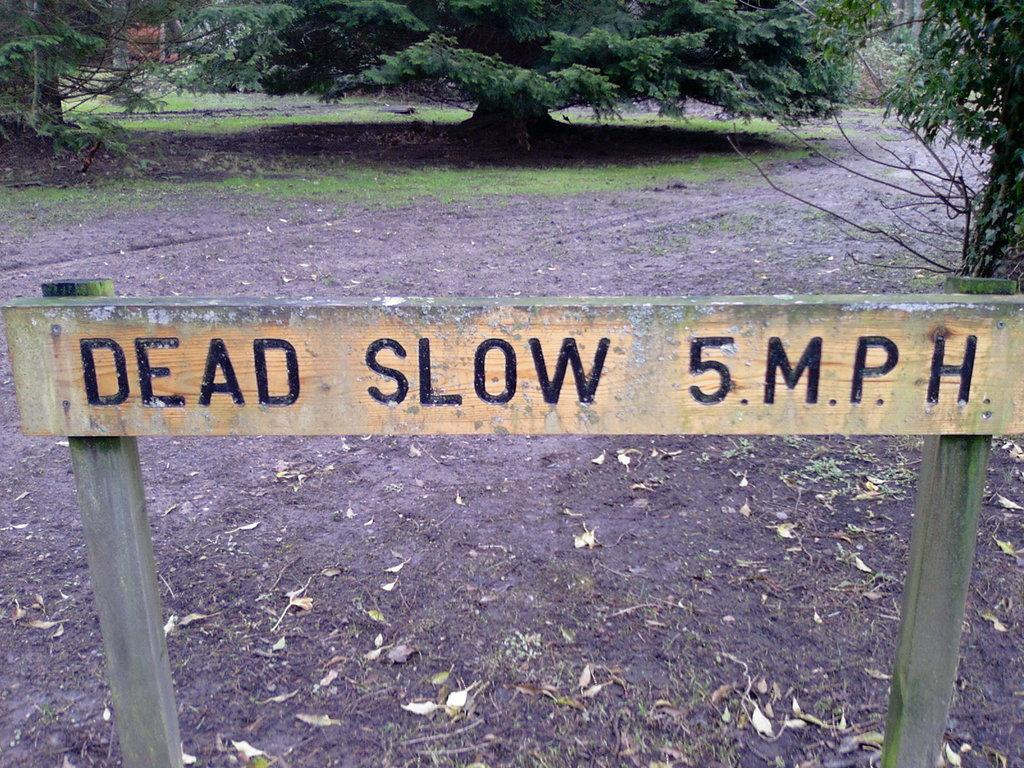What is the wooden object with writing on it in the image? There is a wooden object with writing on it in the image. What can be seen in the background of the image? There are trees in the background of the image. What type of vegetation is visible in the image? There is grass visible in the image. What is present on the ground in the image? Leaves are present on the ground in the image. How many ants can be seen carrying leaves in the image? There are no ants present in the image, so it is not possible to determine how many ants might be carrying leaves. 